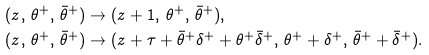Convert formula to latex. <formula><loc_0><loc_0><loc_500><loc_500>( z , \, \theta ^ { + } , \, \bar { \theta } ^ { + } ) & \to ( z + 1 , \, \theta ^ { + } , \, \bar { \theta } ^ { + } ) , \\ ( z , \, \theta ^ { + } , \, \bar { \theta } ^ { + } ) & \to ( z + \tau + \bar { \theta } ^ { + } \delta ^ { + } + \theta ^ { + } \bar { \delta } ^ { + } , \, \theta ^ { + } + \delta ^ { + } , \, \bar { \theta } ^ { + } + \bar { \delta } ^ { + } ) .</formula> 